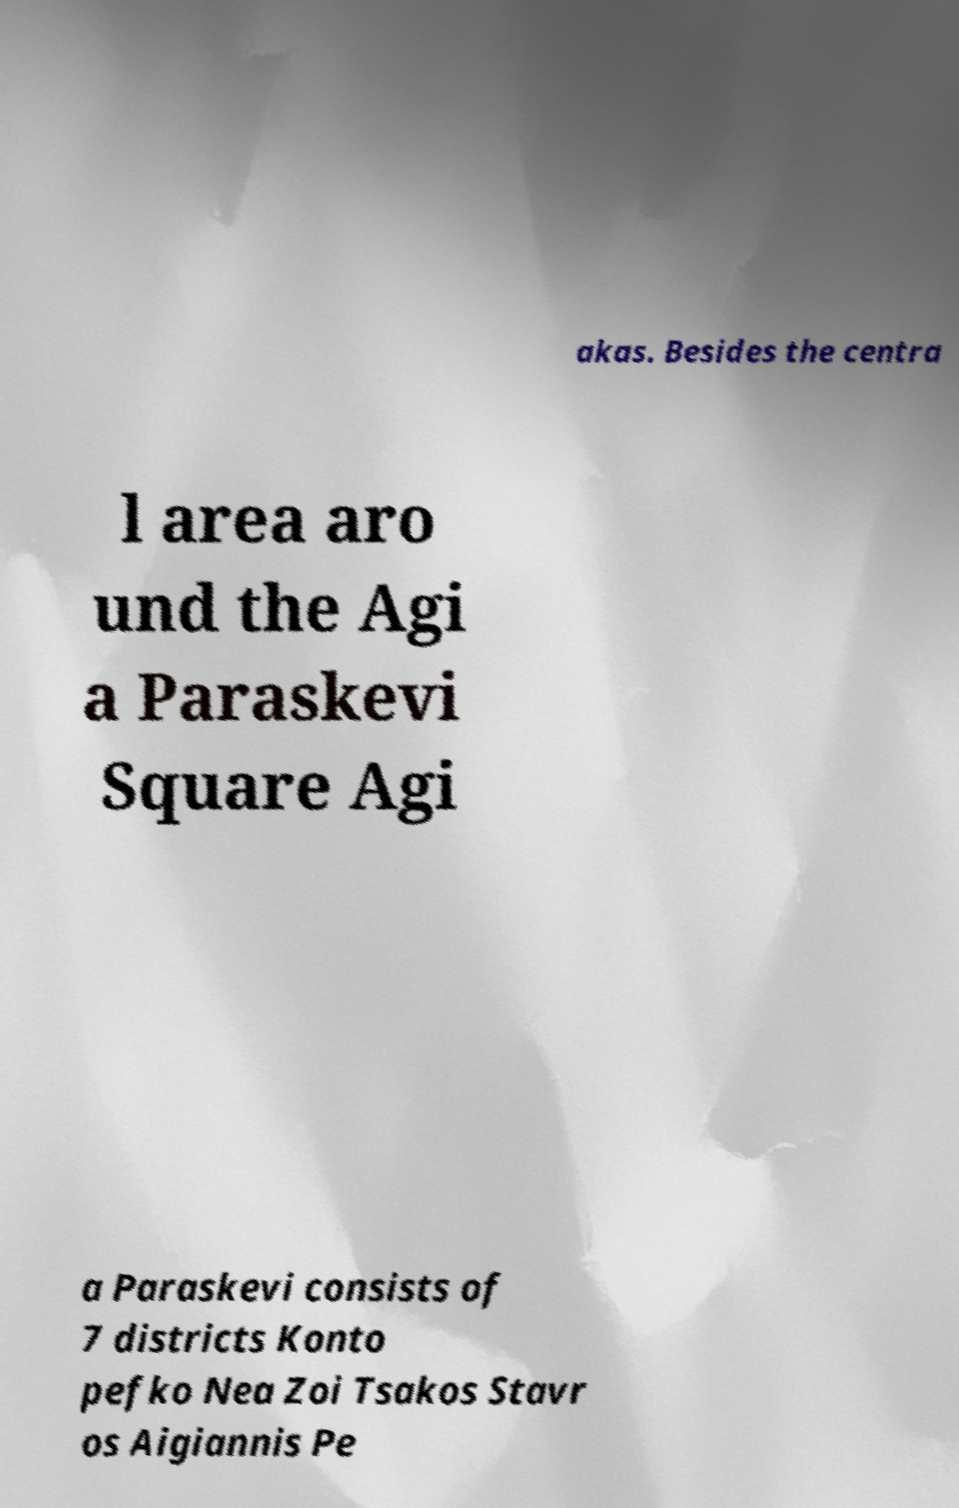For documentation purposes, I need the text within this image transcribed. Could you provide that? akas. Besides the centra l area aro und the Agi a Paraskevi Square Agi a Paraskevi consists of 7 districts Konto pefko Nea Zoi Tsakos Stavr os Aigiannis Pe 